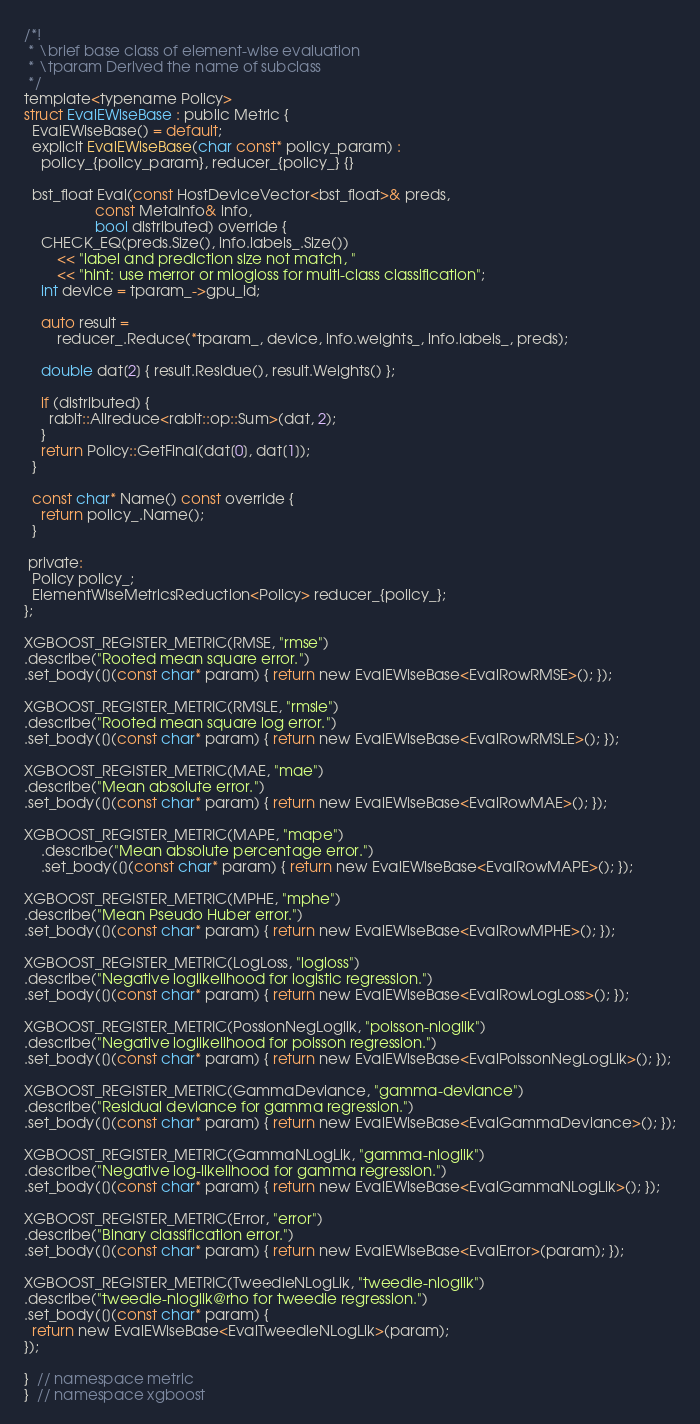<code> <loc_0><loc_0><loc_500><loc_500><_Cuda_>/*!
 * \brief base class of element-wise evaluation
 * \tparam Derived the name of subclass
 */
template<typename Policy>
struct EvalEWiseBase : public Metric {
  EvalEWiseBase() = default;
  explicit EvalEWiseBase(char const* policy_param) :
    policy_{policy_param}, reducer_{policy_} {}

  bst_float Eval(const HostDeviceVector<bst_float>& preds,
                 const MetaInfo& info,
                 bool distributed) override {
    CHECK_EQ(preds.Size(), info.labels_.Size())
        << "label and prediction size not match, "
        << "hint: use merror or mlogloss for multi-class classification";
    int device = tparam_->gpu_id;

    auto result =
        reducer_.Reduce(*tparam_, device, info.weights_, info.labels_, preds);

    double dat[2] { result.Residue(), result.Weights() };

    if (distributed) {
      rabit::Allreduce<rabit::op::Sum>(dat, 2);
    }
    return Policy::GetFinal(dat[0], dat[1]);
  }

  const char* Name() const override {
    return policy_.Name();
  }

 private:
  Policy policy_;
  ElementWiseMetricsReduction<Policy> reducer_{policy_};
};

XGBOOST_REGISTER_METRIC(RMSE, "rmse")
.describe("Rooted mean square error.")
.set_body([](const char* param) { return new EvalEWiseBase<EvalRowRMSE>(); });

XGBOOST_REGISTER_METRIC(RMSLE, "rmsle")
.describe("Rooted mean square log error.")
.set_body([](const char* param) { return new EvalEWiseBase<EvalRowRMSLE>(); });

XGBOOST_REGISTER_METRIC(MAE, "mae")
.describe("Mean absolute error.")
.set_body([](const char* param) { return new EvalEWiseBase<EvalRowMAE>(); });

XGBOOST_REGISTER_METRIC(MAPE, "mape")
    .describe("Mean absolute percentage error.")
    .set_body([](const char* param) { return new EvalEWiseBase<EvalRowMAPE>(); });

XGBOOST_REGISTER_METRIC(MPHE, "mphe")
.describe("Mean Pseudo Huber error.")
.set_body([](const char* param) { return new EvalEWiseBase<EvalRowMPHE>(); });

XGBOOST_REGISTER_METRIC(LogLoss, "logloss")
.describe("Negative loglikelihood for logistic regression.")
.set_body([](const char* param) { return new EvalEWiseBase<EvalRowLogLoss>(); });

XGBOOST_REGISTER_METRIC(PossionNegLoglik, "poisson-nloglik")
.describe("Negative loglikelihood for poisson regression.")
.set_body([](const char* param) { return new EvalEWiseBase<EvalPoissonNegLogLik>(); });

XGBOOST_REGISTER_METRIC(GammaDeviance, "gamma-deviance")
.describe("Residual deviance for gamma regression.")
.set_body([](const char* param) { return new EvalEWiseBase<EvalGammaDeviance>(); });

XGBOOST_REGISTER_METRIC(GammaNLogLik, "gamma-nloglik")
.describe("Negative log-likelihood for gamma regression.")
.set_body([](const char* param) { return new EvalEWiseBase<EvalGammaNLogLik>(); });

XGBOOST_REGISTER_METRIC(Error, "error")
.describe("Binary classification error.")
.set_body([](const char* param) { return new EvalEWiseBase<EvalError>(param); });

XGBOOST_REGISTER_METRIC(TweedieNLogLik, "tweedie-nloglik")
.describe("tweedie-nloglik@rho for tweedie regression.")
.set_body([](const char* param) {
  return new EvalEWiseBase<EvalTweedieNLogLik>(param);
});

}  // namespace metric
}  // namespace xgboost
</code> 